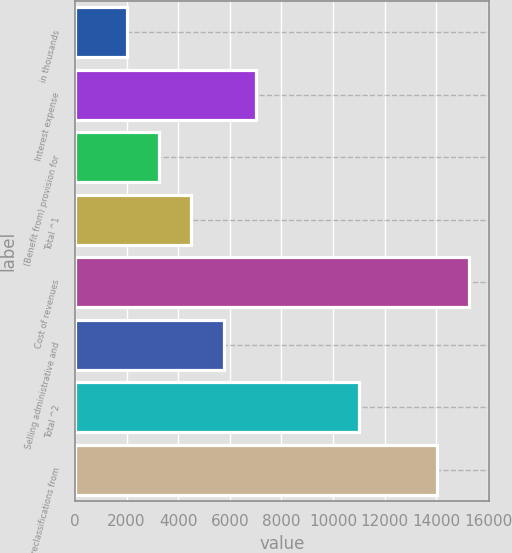Convert chart to OTSL. <chart><loc_0><loc_0><loc_500><loc_500><bar_chart><fcel>in thousands<fcel>Interest expense<fcel>(Benefit from) provision for<fcel>Total ^1<fcel>Cost of revenues<fcel>Selling administrative and<fcel>Total ^2<fcel>Total reclassifications from<nl><fcel>2013<fcel>7014.2<fcel>3263.3<fcel>4513.6<fcel>15253.3<fcel>5763.9<fcel>11011<fcel>14003<nl></chart> 